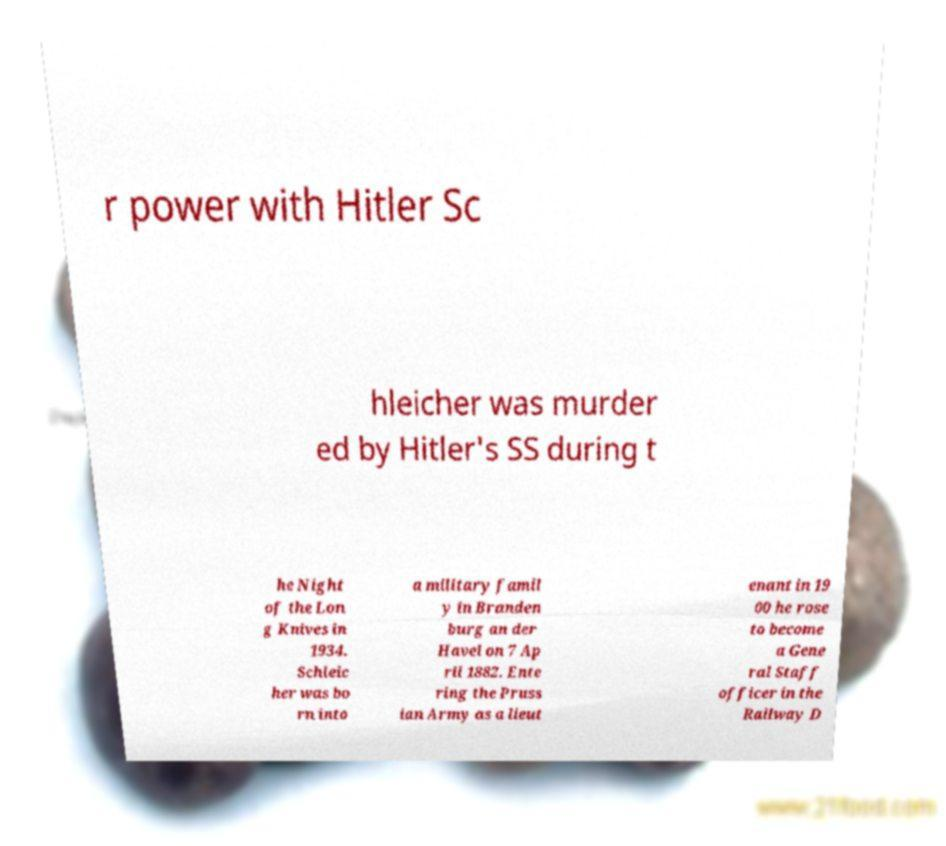Please identify and transcribe the text found in this image. r power with Hitler Sc hleicher was murder ed by Hitler's SS during t he Night of the Lon g Knives in 1934. Schleic her was bo rn into a military famil y in Branden burg an der Havel on 7 Ap ril 1882. Ente ring the Pruss ian Army as a lieut enant in 19 00 he rose to become a Gene ral Staff officer in the Railway D 